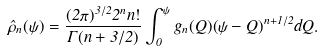Convert formula to latex. <formula><loc_0><loc_0><loc_500><loc_500>\hat { \rho } _ { n } ( \psi ) = \frac { ( 2 \pi ) ^ { 3 / 2 } 2 ^ { n } n ! } { \Gamma ( n + 3 / 2 ) } \int _ { 0 } ^ { \psi } g _ { n } ( Q ) ( \psi - Q ) ^ { n + 1 / 2 } d Q .</formula> 